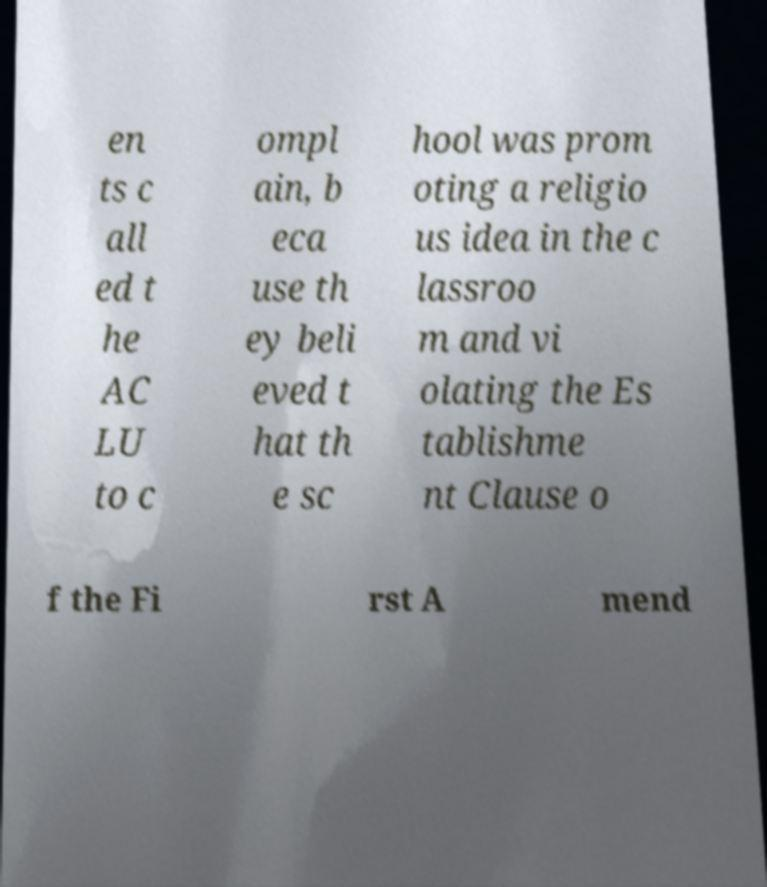Please read and relay the text visible in this image. What does it say? en ts c all ed t he AC LU to c ompl ain, b eca use th ey beli eved t hat th e sc hool was prom oting a religio us idea in the c lassroo m and vi olating the Es tablishme nt Clause o f the Fi rst A mend 